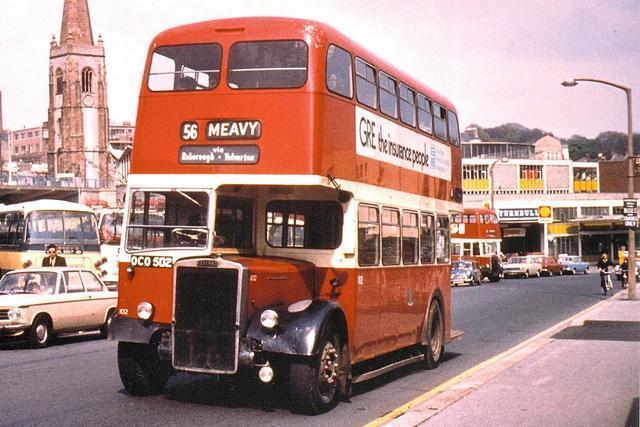Why does the vehicle have two levels?
Choose the right answer and clarify with the format: 'Answer: answer
Rationale: rationale.'
Options: For deliveries, for speed, for sightseeing, for decoration. Answer: for sightseeing.
Rationale: The bus is for tourists. 